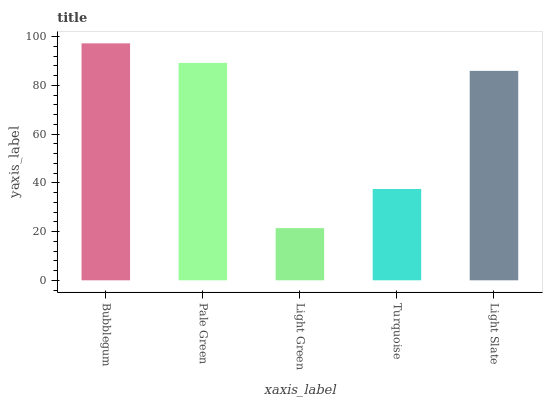Is Light Green the minimum?
Answer yes or no. Yes. Is Bubblegum the maximum?
Answer yes or no. Yes. Is Pale Green the minimum?
Answer yes or no. No. Is Pale Green the maximum?
Answer yes or no. No. Is Bubblegum greater than Pale Green?
Answer yes or no. Yes. Is Pale Green less than Bubblegum?
Answer yes or no. Yes. Is Pale Green greater than Bubblegum?
Answer yes or no. No. Is Bubblegum less than Pale Green?
Answer yes or no. No. Is Light Slate the high median?
Answer yes or no. Yes. Is Light Slate the low median?
Answer yes or no. Yes. Is Turquoise the high median?
Answer yes or no. No. Is Turquoise the low median?
Answer yes or no. No. 